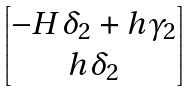Convert formula to latex. <formula><loc_0><loc_0><loc_500><loc_500>\begin{bmatrix} - H \delta _ { 2 } + h \gamma _ { 2 } \\ h \delta _ { 2 } \end{bmatrix}</formula> 